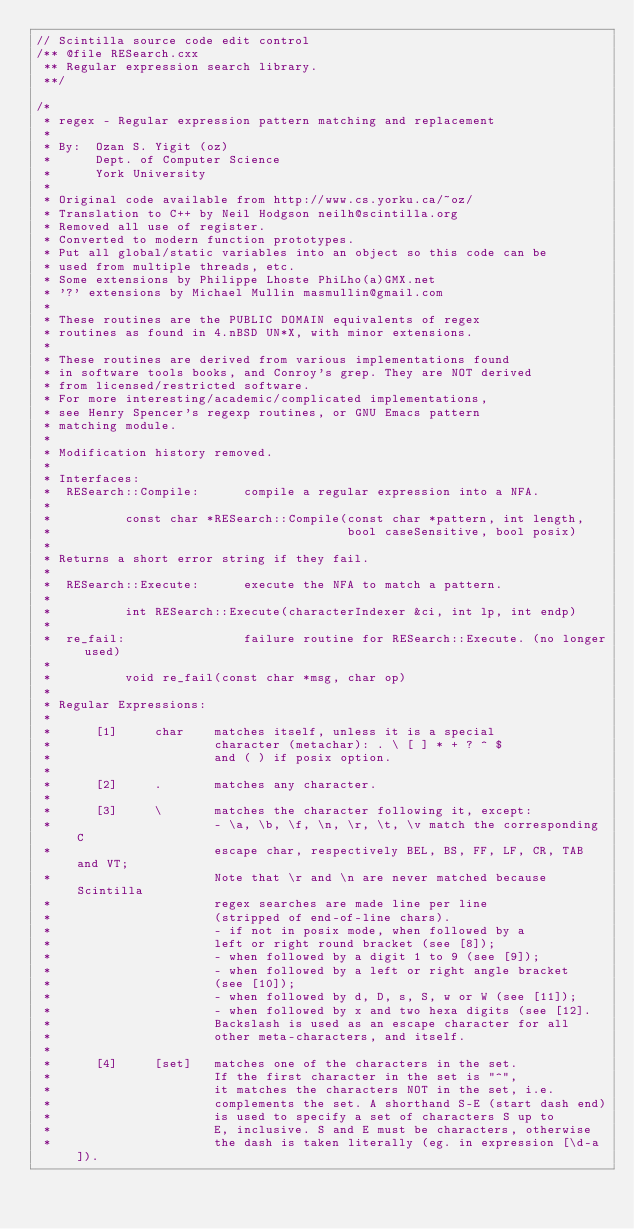<code> <loc_0><loc_0><loc_500><loc_500><_C++_>// Scintilla source code edit control
/** @file RESearch.cxx
 ** Regular expression search library.
 **/

/*
 * regex - Regular expression pattern matching and replacement
 *
 * By:  Ozan S. Yigit (oz)
 *      Dept. of Computer Science
 *      York University
 *
 * Original code available from http://www.cs.yorku.ca/~oz/
 * Translation to C++ by Neil Hodgson neilh@scintilla.org
 * Removed all use of register.
 * Converted to modern function prototypes.
 * Put all global/static variables into an object so this code can be
 * used from multiple threads, etc.
 * Some extensions by Philippe Lhoste PhiLho(a)GMX.net
 * '?' extensions by Michael Mullin masmullin@gmail.com
 *
 * These routines are the PUBLIC DOMAIN equivalents of regex
 * routines as found in 4.nBSD UN*X, with minor extensions.
 *
 * These routines are derived from various implementations found
 * in software tools books, and Conroy's grep. They are NOT derived
 * from licensed/restricted software.
 * For more interesting/academic/complicated implementations,
 * see Henry Spencer's regexp routines, or GNU Emacs pattern
 * matching module.
 *
 * Modification history removed.
 *
 * Interfaces:
 *  RESearch::Compile:      compile a regular expression into a NFA.
 *
 *          const char *RESearch::Compile(const char *pattern, int length,
 *                                        bool caseSensitive, bool posix)
 *
 * Returns a short error string if they fail.
 *
 *  RESearch::Execute:      execute the NFA to match a pattern.
 *
 *          int RESearch::Execute(characterIndexer &ci, int lp, int endp)
 *
 *  re_fail:                failure routine for RESearch::Execute. (no longer used)
 *
 *          void re_fail(const char *msg, char op)
 *
 * Regular Expressions:
 *
 *      [1]     char    matches itself, unless it is a special
 *                      character (metachar): . \ [ ] * + ? ^ $
 *                      and ( ) if posix option.
 *
 *      [2]     .       matches any character.
 *
 *      [3]     \       matches the character following it, except:
 *                      - \a, \b, \f, \n, \r, \t, \v match the corresponding C
 *                      escape char, respectively BEL, BS, FF, LF, CR, TAB and VT;
 *                      Note that \r and \n are never matched because Scintilla
 *                      regex searches are made line per line
 *                      (stripped of end-of-line chars).
 *                      - if not in posix mode, when followed by a
 *                      left or right round bracket (see [8]);
 *                      - when followed by a digit 1 to 9 (see [9]);
 *                      - when followed by a left or right angle bracket
 *                      (see [10]);
 *                      - when followed by d, D, s, S, w or W (see [11]);
 *                      - when followed by x and two hexa digits (see [12].
 *                      Backslash is used as an escape character for all
 *                      other meta-characters, and itself.
 *
 *      [4]     [set]   matches one of the characters in the set.
 *                      If the first character in the set is "^",
 *                      it matches the characters NOT in the set, i.e.
 *                      complements the set. A shorthand S-E (start dash end)
 *                      is used to specify a set of characters S up to
 *                      E, inclusive. S and E must be characters, otherwise
 *                      the dash is taken literally (eg. in expression [\d-a]).</code> 